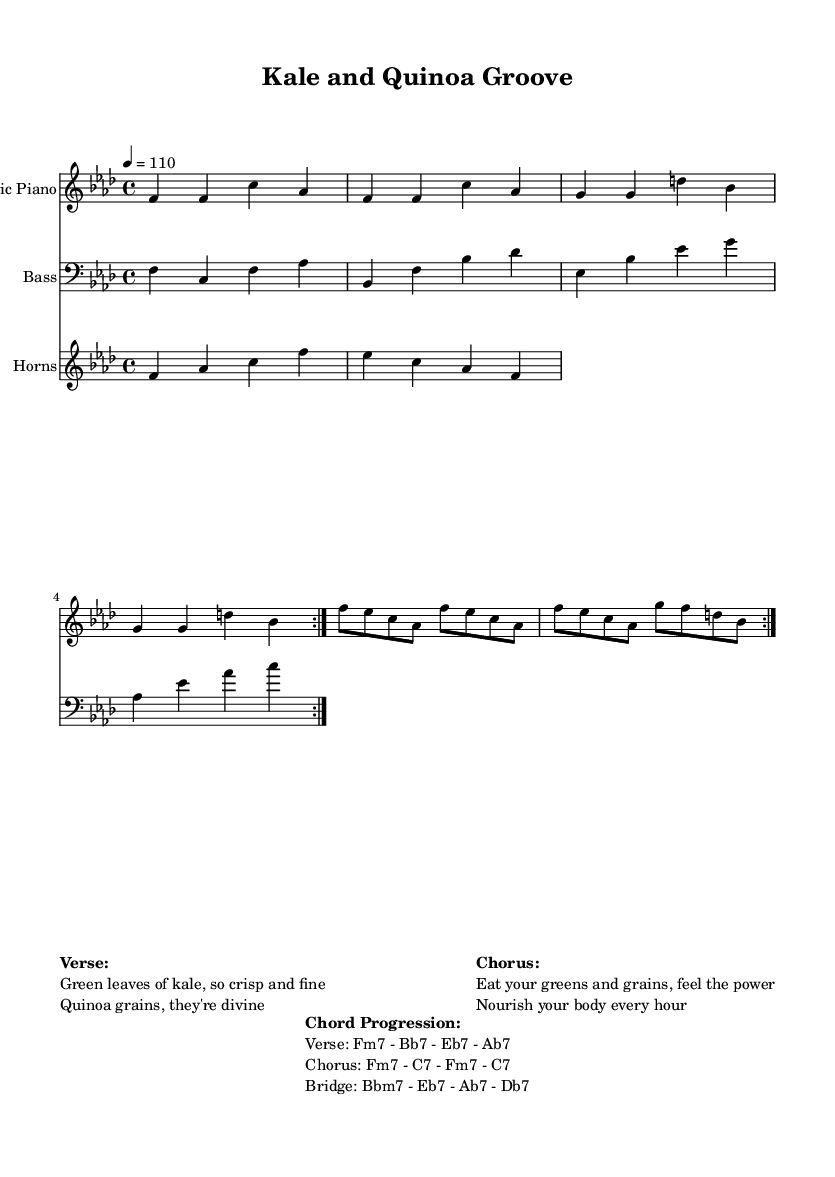What is the key signature of this music? The key signature is F minor, which has four flats (B, E, A, D).
Answer: F minor What is the time signature of this piece? The time signature is 4/4, indicating four beats per measure.
Answer: 4/4 What is the tempo marking for this piece? The tempo marking is 4 beats per minute at 110, indicating a moderate pace.
Answer: 110 What instruments are included in the score? The score features Electric Piano, Bass, and Horns as indicated in the instrument names.
Answer: Electric Piano, Bass, Horns What are the chord changes for the verse? The chord progression for the verse is Fm7 - Bb7 - Eb7 - Ab7, as shown in the markup section under "Chord Progression."
Answer: Fm7 - Bb7 - Eb7 - Ab7 How many times is the electric piano section repeated? The electric piano section is repeated twice, indicated by the "repeat volta 2" notations.
Answer: Twice What is the lyrical theme of the chorus? The lyrics in the chorus celebrate the benefits of consuming greens and grains for nourishment.
Answer: Celebrate nutrition 